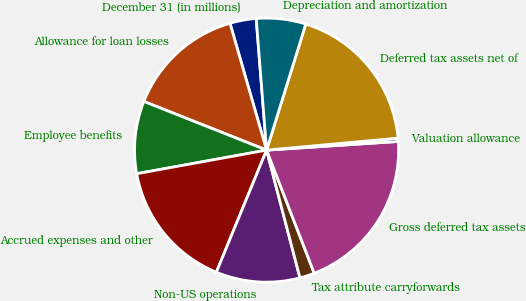Convert chart. <chart><loc_0><loc_0><loc_500><loc_500><pie_chart><fcel>December 31 (in millions)<fcel>Allowance for loan losses<fcel>Employee benefits<fcel>Accrued expenses and other<fcel>Non-US operations<fcel>Tax attribute carryforwards<fcel>Gross deferred tax assets<fcel>Valuation allowance<fcel>Deferred tax assets net of<fcel>Depreciation and amortization<nl><fcel>3.22%<fcel>14.52%<fcel>8.87%<fcel>15.93%<fcel>10.28%<fcel>1.81%<fcel>20.17%<fcel>0.4%<fcel>18.76%<fcel>6.05%<nl></chart> 